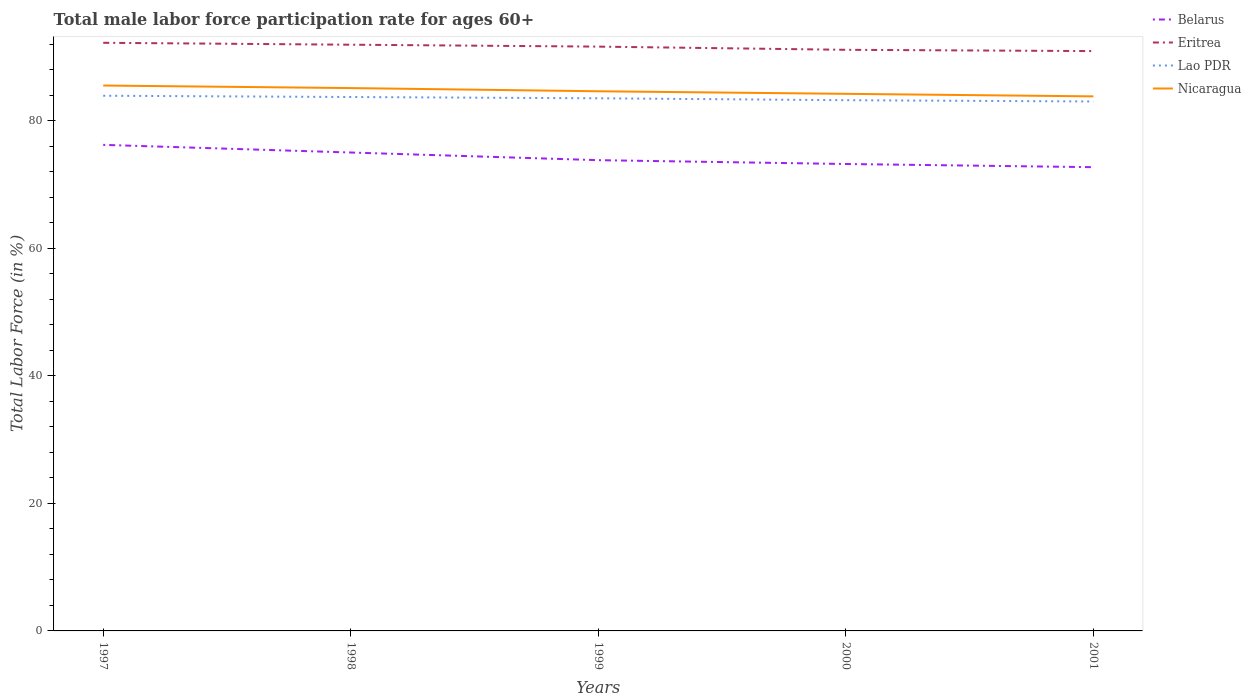How many different coloured lines are there?
Keep it short and to the point. 4. Does the line corresponding to Lao PDR intersect with the line corresponding to Eritrea?
Keep it short and to the point. No. Is the number of lines equal to the number of legend labels?
Your response must be concise. Yes. Across all years, what is the maximum male labor force participation rate in Nicaragua?
Offer a terse response. 83.8. What is the total male labor force participation rate in Belarus in the graph?
Ensure brevity in your answer.  2.4. What is the difference between the highest and the second highest male labor force participation rate in Eritrea?
Your response must be concise. 1.3. Is the male labor force participation rate in Belarus strictly greater than the male labor force participation rate in Nicaragua over the years?
Provide a succinct answer. Yes. How many lines are there?
Give a very brief answer. 4. What is the difference between two consecutive major ticks on the Y-axis?
Offer a terse response. 20. Does the graph contain any zero values?
Give a very brief answer. No. Does the graph contain grids?
Your answer should be compact. No. Where does the legend appear in the graph?
Keep it short and to the point. Top right. What is the title of the graph?
Provide a short and direct response. Total male labor force participation rate for ages 60+. What is the Total Labor Force (in %) of Belarus in 1997?
Ensure brevity in your answer.  76.2. What is the Total Labor Force (in %) of Eritrea in 1997?
Ensure brevity in your answer.  92.2. What is the Total Labor Force (in %) in Lao PDR in 1997?
Provide a short and direct response. 83.9. What is the Total Labor Force (in %) of Nicaragua in 1997?
Provide a succinct answer. 85.5. What is the Total Labor Force (in %) of Belarus in 1998?
Ensure brevity in your answer.  75. What is the Total Labor Force (in %) in Eritrea in 1998?
Make the answer very short. 91.9. What is the Total Labor Force (in %) of Lao PDR in 1998?
Keep it short and to the point. 83.7. What is the Total Labor Force (in %) of Nicaragua in 1998?
Keep it short and to the point. 85.1. What is the Total Labor Force (in %) of Belarus in 1999?
Keep it short and to the point. 73.8. What is the Total Labor Force (in %) of Eritrea in 1999?
Make the answer very short. 91.6. What is the Total Labor Force (in %) of Lao PDR in 1999?
Your answer should be very brief. 83.5. What is the Total Labor Force (in %) in Nicaragua in 1999?
Your answer should be compact. 84.6. What is the Total Labor Force (in %) in Belarus in 2000?
Offer a terse response. 73.2. What is the Total Labor Force (in %) of Eritrea in 2000?
Make the answer very short. 91.1. What is the Total Labor Force (in %) in Lao PDR in 2000?
Offer a very short reply. 83.2. What is the Total Labor Force (in %) in Nicaragua in 2000?
Give a very brief answer. 84.2. What is the Total Labor Force (in %) of Belarus in 2001?
Provide a short and direct response. 72.7. What is the Total Labor Force (in %) in Eritrea in 2001?
Keep it short and to the point. 90.9. What is the Total Labor Force (in %) in Lao PDR in 2001?
Your response must be concise. 83. What is the Total Labor Force (in %) in Nicaragua in 2001?
Ensure brevity in your answer.  83.8. Across all years, what is the maximum Total Labor Force (in %) of Belarus?
Offer a terse response. 76.2. Across all years, what is the maximum Total Labor Force (in %) of Eritrea?
Your response must be concise. 92.2. Across all years, what is the maximum Total Labor Force (in %) of Lao PDR?
Provide a succinct answer. 83.9. Across all years, what is the maximum Total Labor Force (in %) of Nicaragua?
Provide a short and direct response. 85.5. Across all years, what is the minimum Total Labor Force (in %) of Belarus?
Make the answer very short. 72.7. Across all years, what is the minimum Total Labor Force (in %) of Eritrea?
Provide a short and direct response. 90.9. Across all years, what is the minimum Total Labor Force (in %) in Nicaragua?
Your answer should be very brief. 83.8. What is the total Total Labor Force (in %) of Belarus in the graph?
Provide a succinct answer. 370.9. What is the total Total Labor Force (in %) of Eritrea in the graph?
Make the answer very short. 457.7. What is the total Total Labor Force (in %) in Lao PDR in the graph?
Your response must be concise. 417.3. What is the total Total Labor Force (in %) of Nicaragua in the graph?
Your answer should be very brief. 423.2. What is the difference between the Total Labor Force (in %) of Belarus in 1997 and that in 1998?
Your response must be concise. 1.2. What is the difference between the Total Labor Force (in %) of Eritrea in 1997 and that in 1998?
Give a very brief answer. 0.3. What is the difference between the Total Labor Force (in %) in Belarus in 1997 and that in 1999?
Your answer should be very brief. 2.4. What is the difference between the Total Labor Force (in %) of Nicaragua in 1997 and that in 1999?
Ensure brevity in your answer.  0.9. What is the difference between the Total Labor Force (in %) in Lao PDR in 1997 and that in 2000?
Your response must be concise. 0.7. What is the difference between the Total Labor Force (in %) of Belarus in 1997 and that in 2001?
Keep it short and to the point. 3.5. What is the difference between the Total Labor Force (in %) in Eritrea in 1997 and that in 2001?
Your response must be concise. 1.3. What is the difference between the Total Labor Force (in %) in Nicaragua in 1997 and that in 2001?
Your response must be concise. 1.7. What is the difference between the Total Labor Force (in %) in Belarus in 1998 and that in 1999?
Your answer should be compact. 1.2. What is the difference between the Total Labor Force (in %) in Eritrea in 1998 and that in 1999?
Give a very brief answer. 0.3. What is the difference between the Total Labor Force (in %) of Belarus in 1998 and that in 2000?
Offer a very short reply. 1.8. What is the difference between the Total Labor Force (in %) of Lao PDR in 1998 and that in 2000?
Offer a terse response. 0.5. What is the difference between the Total Labor Force (in %) in Nicaragua in 1998 and that in 2000?
Your answer should be very brief. 0.9. What is the difference between the Total Labor Force (in %) in Eritrea in 1998 and that in 2001?
Ensure brevity in your answer.  1. What is the difference between the Total Labor Force (in %) of Belarus in 1999 and that in 2000?
Offer a very short reply. 0.6. What is the difference between the Total Labor Force (in %) of Eritrea in 1999 and that in 2000?
Your answer should be compact. 0.5. What is the difference between the Total Labor Force (in %) in Nicaragua in 1999 and that in 2000?
Offer a terse response. 0.4. What is the difference between the Total Labor Force (in %) in Nicaragua in 1999 and that in 2001?
Ensure brevity in your answer.  0.8. What is the difference between the Total Labor Force (in %) in Eritrea in 2000 and that in 2001?
Your response must be concise. 0.2. What is the difference between the Total Labor Force (in %) in Lao PDR in 2000 and that in 2001?
Provide a succinct answer. 0.2. What is the difference between the Total Labor Force (in %) of Belarus in 1997 and the Total Labor Force (in %) of Eritrea in 1998?
Your response must be concise. -15.7. What is the difference between the Total Labor Force (in %) of Eritrea in 1997 and the Total Labor Force (in %) of Lao PDR in 1998?
Keep it short and to the point. 8.5. What is the difference between the Total Labor Force (in %) of Eritrea in 1997 and the Total Labor Force (in %) of Nicaragua in 1998?
Your answer should be very brief. 7.1. What is the difference between the Total Labor Force (in %) of Lao PDR in 1997 and the Total Labor Force (in %) of Nicaragua in 1998?
Your answer should be compact. -1.2. What is the difference between the Total Labor Force (in %) of Belarus in 1997 and the Total Labor Force (in %) of Eritrea in 1999?
Provide a succinct answer. -15.4. What is the difference between the Total Labor Force (in %) in Belarus in 1997 and the Total Labor Force (in %) in Lao PDR in 1999?
Give a very brief answer. -7.3. What is the difference between the Total Labor Force (in %) in Eritrea in 1997 and the Total Labor Force (in %) in Lao PDR in 1999?
Provide a succinct answer. 8.7. What is the difference between the Total Labor Force (in %) in Eritrea in 1997 and the Total Labor Force (in %) in Nicaragua in 1999?
Your answer should be compact. 7.6. What is the difference between the Total Labor Force (in %) of Belarus in 1997 and the Total Labor Force (in %) of Eritrea in 2000?
Your answer should be very brief. -14.9. What is the difference between the Total Labor Force (in %) of Belarus in 1997 and the Total Labor Force (in %) of Lao PDR in 2000?
Your answer should be compact. -7. What is the difference between the Total Labor Force (in %) in Eritrea in 1997 and the Total Labor Force (in %) in Lao PDR in 2000?
Give a very brief answer. 9. What is the difference between the Total Labor Force (in %) in Eritrea in 1997 and the Total Labor Force (in %) in Nicaragua in 2000?
Offer a terse response. 8. What is the difference between the Total Labor Force (in %) of Belarus in 1997 and the Total Labor Force (in %) of Eritrea in 2001?
Your answer should be very brief. -14.7. What is the difference between the Total Labor Force (in %) in Belarus in 1997 and the Total Labor Force (in %) in Nicaragua in 2001?
Give a very brief answer. -7.6. What is the difference between the Total Labor Force (in %) in Eritrea in 1997 and the Total Labor Force (in %) in Lao PDR in 2001?
Your answer should be very brief. 9.2. What is the difference between the Total Labor Force (in %) in Eritrea in 1997 and the Total Labor Force (in %) in Nicaragua in 2001?
Provide a succinct answer. 8.4. What is the difference between the Total Labor Force (in %) of Belarus in 1998 and the Total Labor Force (in %) of Eritrea in 1999?
Offer a terse response. -16.6. What is the difference between the Total Labor Force (in %) in Eritrea in 1998 and the Total Labor Force (in %) in Lao PDR in 1999?
Keep it short and to the point. 8.4. What is the difference between the Total Labor Force (in %) in Eritrea in 1998 and the Total Labor Force (in %) in Nicaragua in 1999?
Offer a terse response. 7.3. What is the difference between the Total Labor Force (in %) in Belarus in 1998 and the Total Labor Force (in %) in Eritrea in 2000?
Offer a very short reply. -16.1. What is the difference between the Total Labor Force (in %) of Lao PDR in 1998 and the Total Labor Force (in %) of Nicaragua in 2000?
Offer a terse response. -0.5. What is the difference between the Total Labor Force (in %) of Belarus in 1998 and the Total Labor Force (in %) of Eritrea in 2001?
Provide a short and direct response. -15.9. What is the difference between the Total Labor Force (in %) of Belarus in 1998 and the Total Labor Force (in %) of Nicaragua in 2001?
Your response must be concise. -8.8. What is the difference between the Total Labor Force (in %) of Belarus in 1999 and the Total Labor Force (in %) of Eritrea in 2000?
Ensure brevity in your answer.  -17.3. What is the difference between the Total Labor Force (in %) in Belarus in 1999 and the Total Labor Force (in %) in Nicaragua in 2000?
Provide a succinct answer. -10.4. What is the difference between the Total Labor Force (in %) in Eritrea in 1999 and the Total Labor Force (in %) in Nicaragua in 2000?
Provide a succinct answer. 7.4. What is the difference between the Total Labor Force (in %) in Lao PDR in 1999 and the Total Labor Force (in %) in Nicaragua in 2000?
Provide a succinct answer. -0.7. What is the difference between the Total Labor Force (in %) in Belarus in 1999 and the Total Labor Force (in %) in Eritrea in 2001?
Your answer should be very brief. -17.1. What is the difference between the Total Labor Force (in %) of Eritrea in 1999 and the Total Labor Force (in %) of Lao PDR in 2001?
Your response must be concise. 8.6. What is the difference between the Total Labor Force (in %) of Eritrea in 1999 and the Total Labor Force (in %) of Nicaragua in 2001?
Your response must be concise. 7.8. What is the difference between the Total Labor Force (in %) in Lao PDR in 1999 and the Total Labor Force (in %) in Nicaragua in 2001?
Your answer should be compact. -0.3. What is the difference between the Total Labor Force (in %) of Belarus in 2000 and the Total Labor Force (in %) of Eritrea in 2001?
Give a very brief answer. -17.7. What is the difference between the Total Labor Force (in %) of Lao PDR in 2000 and the Total Labor Force (in %) of Nicaragua in 2001?
Your answer should be very brief. -0.6. What is the average Total Labor Force (in %) in Belarus per year?
Ensure brevity in your answer.  74.18. What is the average Total Labor Force (in %) in Eritrea per year?
Make the answer very short. 91.54. What is the average Total Labor Force (in %) in Lao PDR per year?
Ensure brevity in your answer.  83.46. What is the average Total Labor Force (in %) of Nicaragua per year?
Ensure brevity in your answer.  84.64. In the year 1997, what is the difference between the Total Labor Force (in %) in Belarus and Total Labor Force (in %) in Lao PDR?
Provide a short and direct response. -7.7. In the year 1997, what is the difference between the Total Labor Force (in %) in Belarus and Total Labor Force (in %) in Nicaragua?
Your response must be concise. -9.3. In the year 1997, what is the difference between the Total Labor Force (in %) in Lao PDR and Total Labor Force (in %) in Nicaragua?
Make the answer very short. -1.6. In the year 1998, what is the difference between the Total Labor Force (in %) of Belarus and Total Labor Force (in %) of Eritrea?
Your answer should be compact. -16.9. In the year 1998, what is the difference between the Total Labor Force (in %) of Belarus and Total Labor Force (in %) of Nicaragua?
Offer a very short reply. -10.1. In the year 1998, what is the difference between the Total Labor Force (in %) of Eritrea and Total Labor Force (in %) of Nicaragua?
Keep it short and to the point. 6.8. In the year 1998, what is the difference between the Total Labor Force (in %) in Lao PDR and Total Labor Force (in %) in Nicaragua?
Keep it short and to the point. -1.4. In the year 1999, what is the difference between the Total Labor Force (in %) in Belarus and Total Labor Force (in %) in Eritrea?
Your response must be concise. -17.8. In the year 1999, what is the difference between the Total Labor Force (in %) of Lao PDR and Total Labor Force (in %) of Nicaragua?
Ensure brevity in your answer.  -1.1. In the year 2000, what is the difference between the Total Labor Force (in %) of Belarus and Total Labor Force (in %) of Eritrea?
Give a very brief answer. -17.9. In the year 2000, what is the difference between the Total Labor Force (in %) of Belarus and Total Labor Force (in %) of Nicaragua?
Your answer should be very brief. -11. In the year 2000, what is the difference between the Total Labor Force (in %) of Eritrea and Total Labor Force (in %) of Nicaragua?
Your response must be concise. 6.9. In the year 2000, what is the difference between the Total Labor Force (in %) of Lao PDR and Total Labor Force (in %) of Nicaragua?
Offer a very short reply. -1. In the year 2001, what is the difference between the Total Labor Force (in %) of Belarus and Total Labor Force (in %) of Eritrea?
Offer a terse response. -18.2. In the year 2001, what is the difference between the Total Labor Force (in %) in Belarus and Total Labor Force (in %) in Lao PDR?
Give a very brief answer. -10.3. In the year 2001, what is the difference between the Total Labor Force (in %) in Lao PDR and Total Labor Force (in %) in Nicaragua?
Ensure brevity in your answer.  -0.8. What is the ratio of the Total Labor Force (in %) in Belarus in 1997 to that in 1998?
Provide a short and direct response. 1.02. What is the ratio of the Total Labor Force (in %) of Eritrea in 1997 to that in 1998?
Your answer should be very brief. 1. What is the ratio of the Total Labor Force (in %) of Lao PDR in 1997 to that in 1998?
Your answer should be compact. 1. What is the ratio of the Total Labor Force (in %) in Belarus in 1997 to that in 1999?
Offer a terse response. 1.03. What is the ratio of the Total Labor Force (in %) of Eritrea in 1997 to that in 1999?
Offer a terse response. 1.01. What is the ratio of the Total Labor Force (in %) of Nicaragua in 1997 to that in 1999?
Your answer should be compact. 1.01. What is the ratio of the Total Labor Force (in %) in Belarus in 1997 to that in 2000?
Provide a short and direct response. 1.04. What is the ratio of the Total Labor Force (in %) of Eritrea in 1997 to that in 2000?
Your response must be concise. 1.01. What is the ratio of the Total Labor Force (in %) in Lao PDR in 1997 to that in 2000?
Offer a very short reply. 1.01. What is the ratio of the Total Labor Force (in %) of Nicaragua in 1997 to that in 2000?
Provide a short and direct response. 1.02. What is the ratio of the Total Labor Force (in %) of Belarus in 1997 to that in 2001?
Provide a succinct answer. 1.05. What is the ratio of the Total Labor Force (in %) of Eritrea in 1997 to that in 2001?
Ensure brevity in your answer.  1.01. What is the ratio of the Total Labor Force (in %) of Lao PDR in 1997 to that in 2001?
Offer a terse response. 1.01. What is the ratio of the Total Labor Force (in %) in Nicaragua in 1997 to that in 2001?
Your answer should be compact. 1.02. What is the ratio of the Total Labor Force (in %) in Belarus in 1998 to that in 1999?
Provide a succinct answer. 1.02. What is the ratio of the Total Labor Force (in %) of Eritrea in 1998 to that in 1999?
Provide a short and direct response. 1. What is the ratio of the Total Labor Force (in %) in Nicaragua in 1998 to that in 1999?
Offer a terse response. 1.01. What is the ratio of the Total Labor Force (in %) in Belarus in 1998 to that in 2000?
Give a very brief answer. 1.02. What is the ratio of the Total Labor Force (in %) in Eritrea in 1998 to that in 2000?
Keep it short and to the point. 1.01. What is the ratio of the Total Labor Force (in %) in Lao PDR in 1998 to that in 2000?
Give a very brief answer. 1.01. What is the ratio of the Total Labor Force (in %) of Nicaragua in 1998 to that in 2000?
Ensure brevity in your answer.  1.01. What is the ratio of the Total Labor Force (in %) of Belarus in 1998 to that in 2001?
Offer a terse response. 1.03. What is the ratio of the Total Labor Force (in %) of Lao PDR in 1998 to that in 2001?
Give a very brief answer. 1.01. What is the ratio of the Total Labor Force (in %) in Nicaragua in 1998 to that in 2001?
Offer a very short reply. 1.02. What is the ratio of the Total Labor Force (in %) of Belarus in 1999 to that in 2000?
Give a very brief answer. 1.01. What is the ratio of the Total Labor Force (in %) in Eritrea in 1999 to that in 2000?
Keep it short and to the point. 1.01. What is the ratio of the Total Labor Force (in %) of Belarus in 1999 to that in 2001?
Your answer should be very brief. 1.02. What is the ratio of the Total Labor Force (in %) of Eritrea in 1999 to that in 2001?
Make the answer very short. 1.01. What is the ratio of the Total Labor Force (in %) in Nicaragua in 1999 to that in 2001?
Keep it short and to the point. 1.01. What is the ratio of the Total Labor Force (in %) of Belarus in 2000 to that in 2001?
Provide a short and direct response. 1.01. What is the ratio of the Total Labor Force (in %) of Eritrea in 2000 to that in 2001?
Offer a terse response. 1. What is the ratio of the Total Labor Force (in %) in Nicaragua in 2000 to that in 2001?
Your answer should be compact. 1. What is the difference between the highest and the second highest Total Labor Force (in %) in Belarus?
Make the answer very short. 1.2. What is the difference between the highest and the second highest Total Labor Force (in %) in Eritrea?
Ensure brevity in your answer.  0.3. What is the difference between the highest and the second highest Total Labor Force (in %) in Lao PDR?
Ensure brevity in your answer.  0.2. What is the difference between the highest and the lowest Total Labor Force (in %) of Lao PDR?
Offer a terse response. 0.9. What is the difference between the highest and the lowest Total Labor Force (in %) in Nicaragua?
Keep it short and to the point. 1.7. 